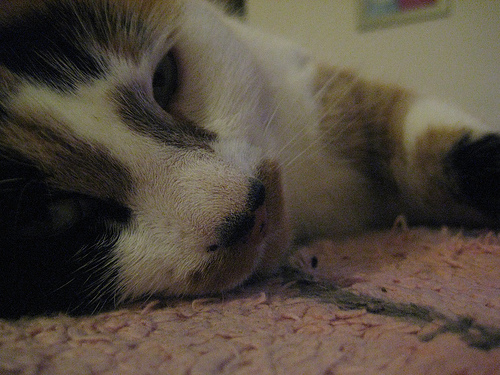<image>
Is the cat behind the picture? No. The cat is not behind the picture. From this viewpoint, the cat appears to be positioned elsewhere in the scene. Where is the cat in relation to the wall? Is it in front of the wall? Yes. The cat is positioned in front of the wall, appearing closer to the camera viewpoint. 